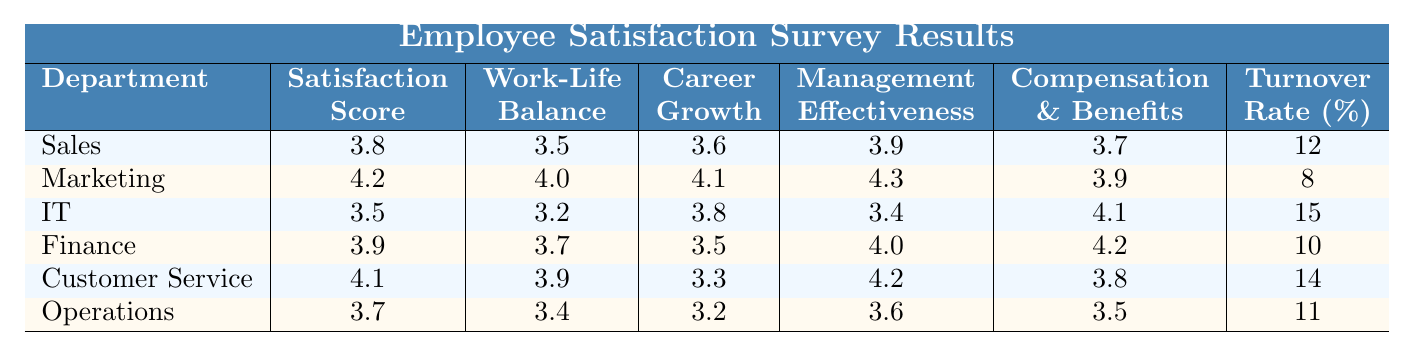What is the satisfaction score for the Marketing department? The table directly shows the satisfaction score for the Marketing department listed under "Satisfaction Score," which is 4.2.
Answer: 4.2 What is the turnover rate for the IT department? Looking at the "Turnover Rate" column, the turnover rate for the IT department is 15%.
Answer: 15% Which department has the highest score in work-life balance? The work-life balance scores are compared, and Marketing has the highest score of 4.0, while all others are lower.
Answer: Marketing What is the average satisfaction score across all departments? To find the average, sum all satisfaction scores (3.8 + 4.2 + 3.5 + 3.9 + 4.1 + 3.7 = 23.2) and divide by the number of departments (6), resulting in 23.2 / 6 = 3.87.
Answer: 3.87 Is the management effectiveness score for Customer Service greater than that for Operations? Comparing the management effectiveness scores, Customer Service has 4.2 while Operations has 3.6, thus yes, Customer Service's score is greater.
Answer: Yes What is the difference in turnover rates between the Marketing and IT departments? The turnover rate for Marketing is 8% and for IT is 15%. The difference is calculated as 15 - 8 = 7%.
Answer: 7% Which department has the lowest score in career growth? The table shows Operations has the lowest career growth score of 3.2.
Answer: Operations What is the highest score for compensation and benefits, and which department does it belong to? The highest compensation and benefits score is found by checking this column; it is 4.2, which belongs to the Finance department.
Answer: Finance Are the work-life balance and satisfaction scores for Sales department higher than those for IT? The work-life balance for Sales is 3.5 and satisfaction is 3.8, while IT has 3.2 and 3.5 respectively. Both scores for Sales are higher than those for IT.
Answer: Yes What department shows the best overall satisfaction based on their scores? By evaluating the satisfaction scores for all departments, Marketing has the highest score of 4.2, indicating it shows the best overall satisfaction.
Answer: Marketing 